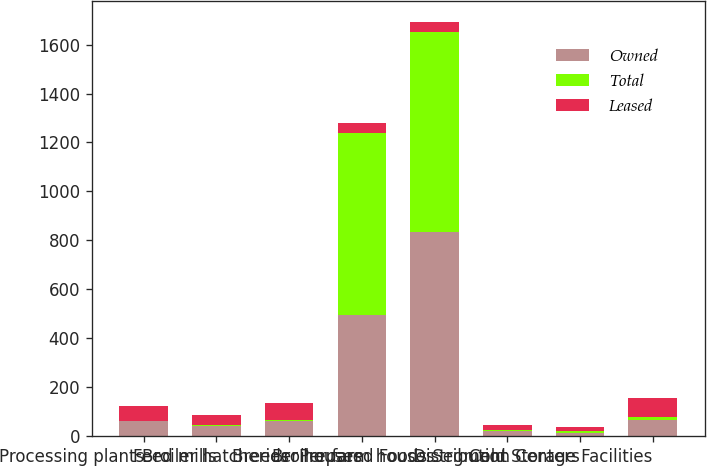Convert chart. <chart><loc_0><loc_0><loc_500><loc_500><stacked_bar_chart><ecel><fcel>Processing plants<fcel>Feed mills<fcel>Broiler hatcheries<fcel>Breeder houses<fcel>Broiler farm houses<fcel>Prepared Foods Segment<fcel>Distribution Centers<fcel>Cold Storage Facilities<nl><fcel>Owned<fcel>61<fcel>42<fcel>62<fcel>493<fcel>834<fcel>22<fcel>14<fcel>65<nl><fcel>Total<fcel>1<fcel>1<fcel>5<fcel>744<fcel>816<fcel>1<fcel>5<fcel>13<nl><fcel>Leased<fcel>62<fcel>43<fcel>67<fcel>42.5<fcel>42.5<fcel>23<fcel>19<fcel>78<nl></chart> 